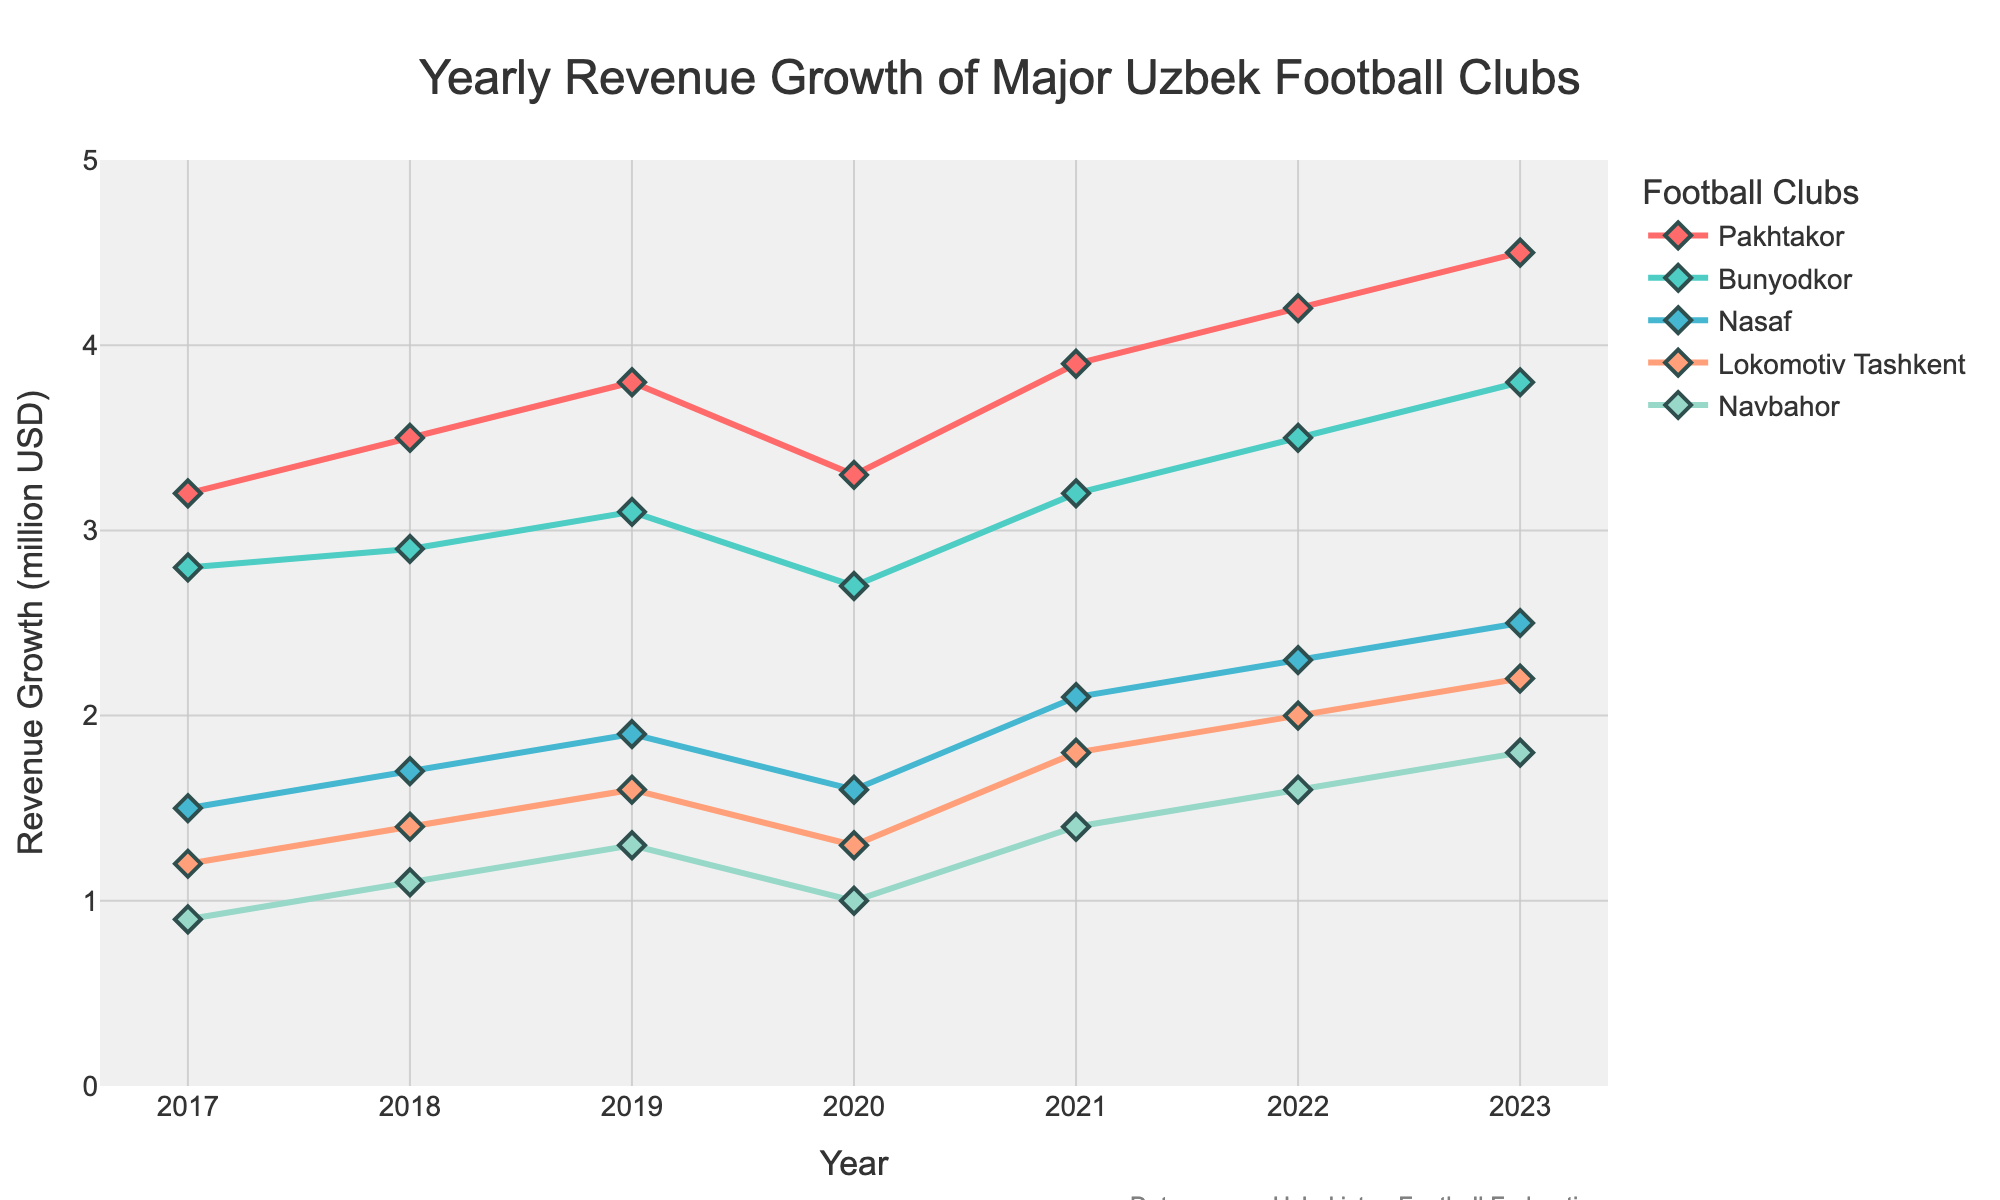What was Pakhtakor's revenue growth in 2019? Look at the point on the line corresponding to Pakhtakor in 2019. It is marked at 3.8 million USD.
Answer: 3.8 million USD Which club had the highest revenue growth in 2023, and what was the value? In 2023, Pakhtakor had the highest point on the chart, indicating the highest revenue growth at 4.5 million USD.
Answer: Pakhtakor, 4.5 million USD How did Lokomotiv Tashkent's revenue growth change from 2020 to 2021? Observe the data points for Lokomotiv Tashkent in 2020 and 2021. It increased from 1.3 million USD to 1.8 million USD. The change is 1.8 - 1.3 = 0.5 million USD.
Answer: Increased by 0.5 million USD Which club had the least revenue growth in 2017 and what was the value? The lowest point in 2017 is for Navbahor, which had a revenue growth of 0.9 million USD.
Answer: Navbahor, 0.9 million USD What's the average revenue growth for Bunyodkor from 2017 to 2023? Sum Bunyodkor's revenue growth values from 2017 to 2023 and divide by the number of years: (2.8 + 2.9 + 3.1 + 2.7 + 3.2 + 3.5 + 3.8) / 7 = 3.14 million USD.
Answer: 3.14 million USD Compare the revenue growth of Nasaf and Navbahor in 2023. Which is higher and by how much? In 2023, Nasaf's revenue growth is 2.5 million USD and Navbahor's is 1.8 million USD. The difference is 2.5 - 1.8 = 0.7 million USD.
Answer: Nasaf is higher by 0.7 million USD Which club has consistently increased its revenue growth each year from 2017 to 2023? Check the upward trends for each club. Pakhtakor and Bunyodkor show consistent increases each year except for a drop in 2020. Pakhtakor shows no declines, hence it has the most consistent increase.
Answer: Pakhtakor What is the total revenue growth for Nasaf from 2018 to 2023? Sum Nasaf's revenue growth values from 2018 to 2023: 1.7 + 1.9 + 1.6 + 2.1 + 2.3 + 2.5 = 12.1 million USD.
Answer: 12.1 million USD How did the revenue growth for Navbahor change overall from 2017 to 2023? Compare Navbahor's revenue growth in 2017 (0.9 million USD) to 2023 (1.8 million USD). The overall change is 1.8 - 0.9 = 0.9 million USD.
Answer: Increased by 0.9 million USD 